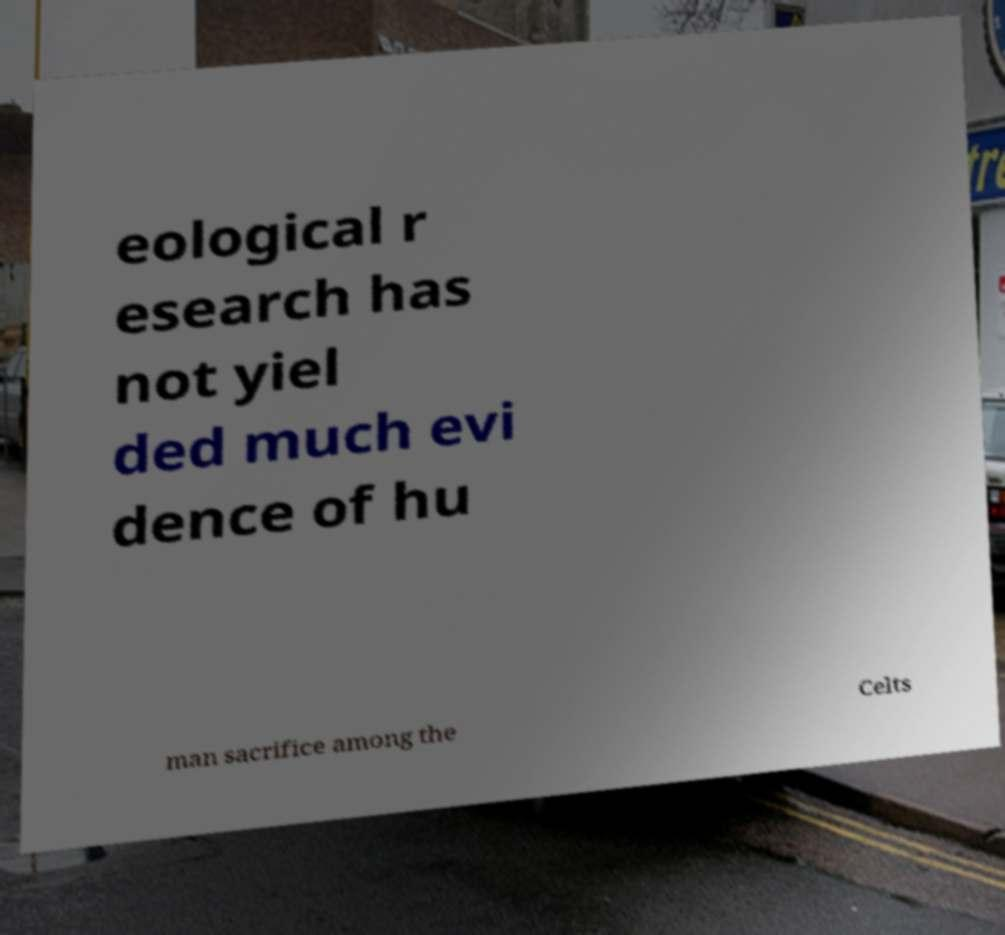Could you extract and type out the text from this image? eological r esearch has not yiel ded much evi dence of hu man sacrifice among the Celts 